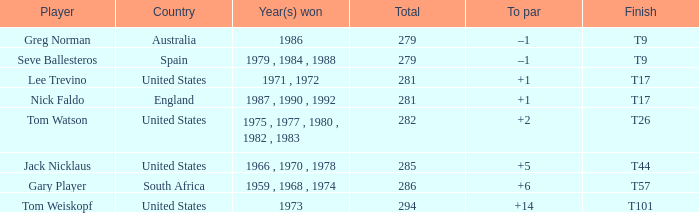Which player is from Australia? Greg Norman. 